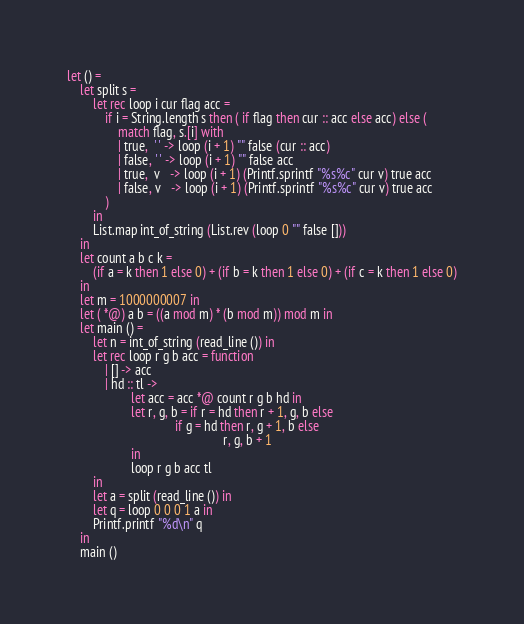<code> <loc_0><loc_0><loc_500><loc_500><_OCaml_>let () =
    let split s =
        let rec loop i cur flag acc =
            if i = String.length s then ( if flag then cur :: acc else acc) else (
                match flag, s.[i] with
                | true,  ' ' -> loop (i + 1) "" false (cur :: acc)
                | false, ' ' -> loop (i + 1) "" false acc
                | true,  v   -> loop (i + 1) (Printf.sprintf "%s%c" cur v) true acc
                | false, v   -> loop (i + 1) (Printf.sprintf "%s%c" cur v) true acc
            )
        in
        List.map int_of_string (List.rev (loop 0 "" false []))
    in
    let count a b c k =
        (if a = k then 1 else 0) + (if b = k then 1 else 0) + (if c = k then 1 else 0)
    in
    let m = 1000000007 in
    let ( *@) a b = ((a mod m) * (b mod m)) mod m in
    let main () =
        let n = int_of_string (read_line ()) in
        let rec loop r g b acc = function
            | [] -> acc
            | hd :: tl ->
                    let acc = acc *@ count r g b hd in
                    let r, g, b = if r = hd then r + 1, g, b else
                                  if g = hd then r, g + 1, b else
                                                 r, g, b + 1
                    in
                    loop r g b acc tl
        in
        let a = split (read_line ()) in
        let q = loop 0 0 0 1 a in
        Printf.printf "%d\n" q
    in
    main ()</code> 